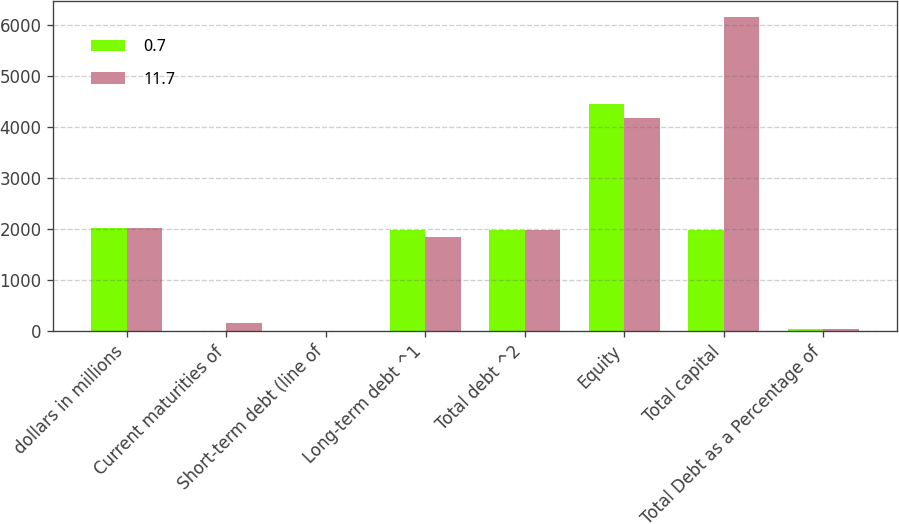<chart> <loc_0><loc_0><loc_500><loc_500><stacked_bar_chart><ecel><fcel>dollars in millions<fcel>Current maturities of<fcel>Short-term debt (line of<fcel>Long-term debt ^1<fcel>Total debt ^2<fcel>Equity<fcel>Total capital<fcel>Total Debt as a Percentage of<nl><fcel>0.7<fcel>2015<fcel>0.1<fcel>0<fcel>1980.3<fcel>1980.4<fcel>4454.2<fcel>1980.3<fcel>30.8<nl><fcel>11.7<fcel>2014<fcel>150.1<fcel>0<fcel>1834.6<fcel>1984.7<fcel>4176.7<fcel>6161.4<fcel>32.2<nl></chart> 